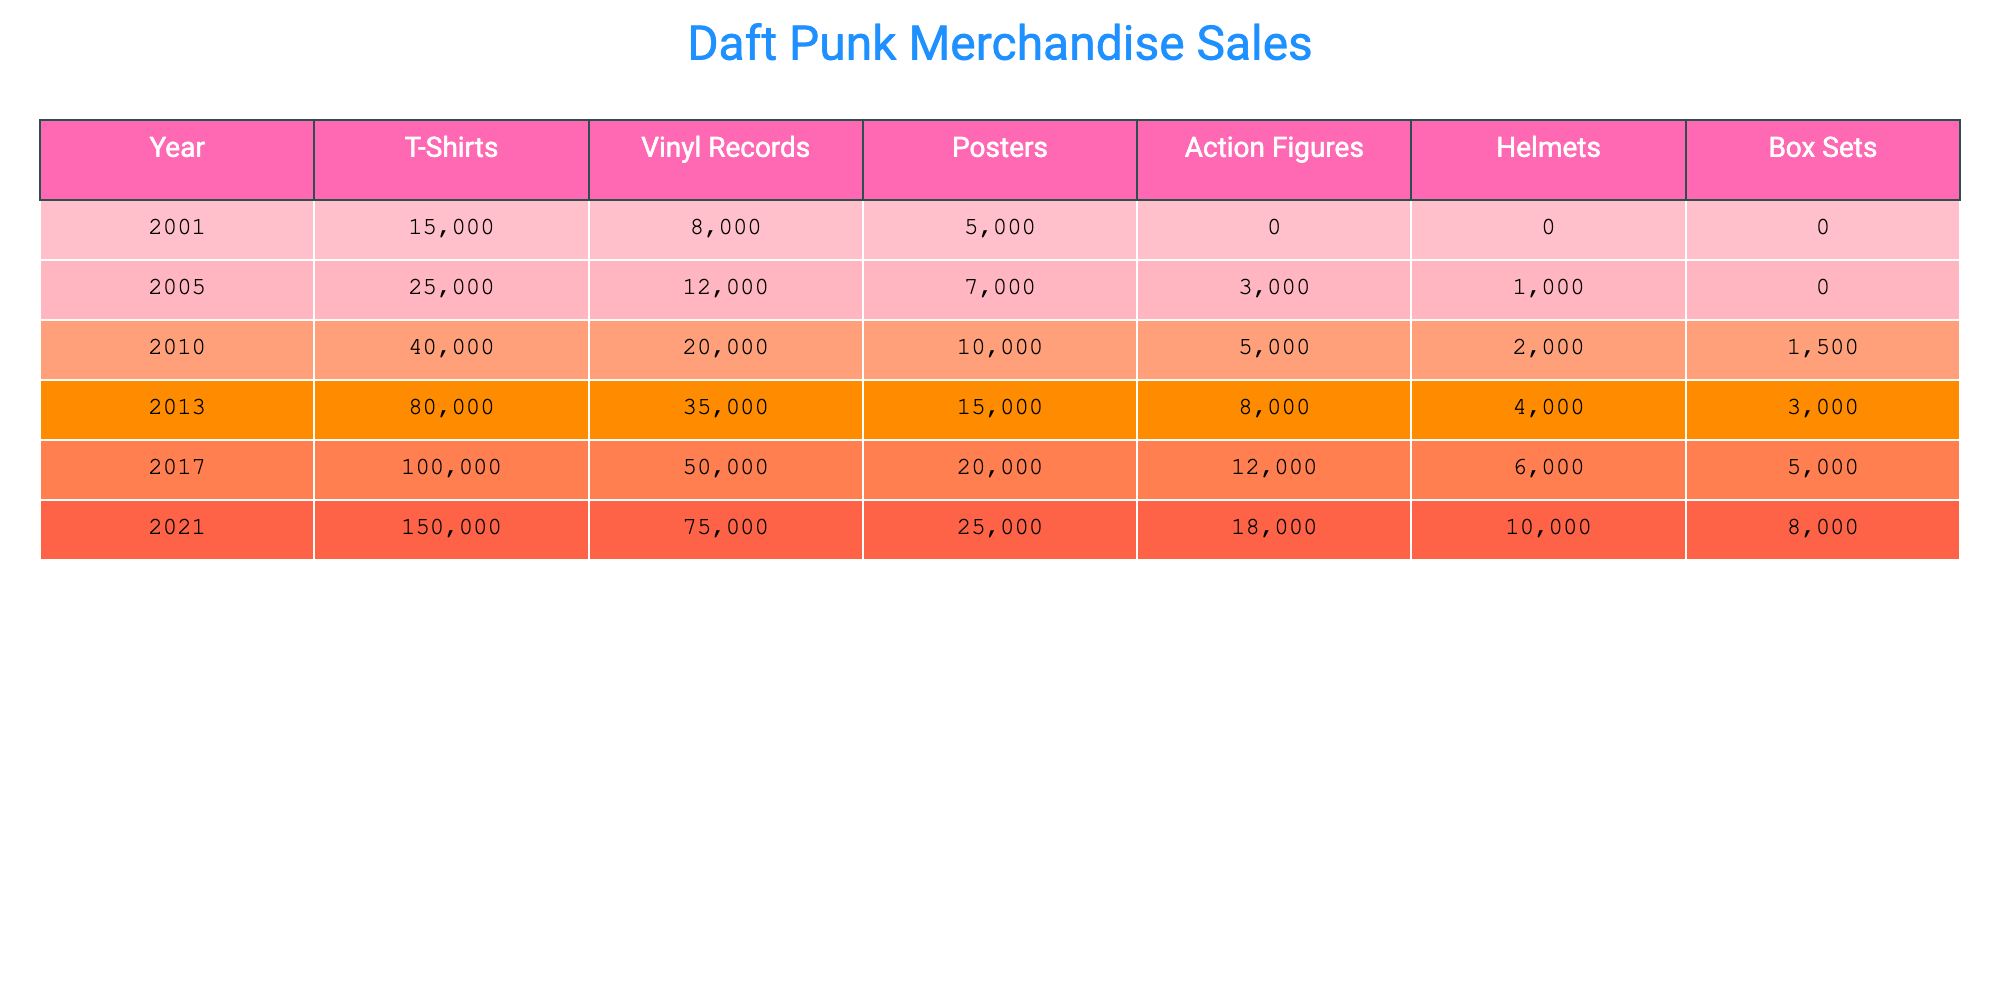What year had the highest merchandise sales for T-Shirts? The highest T-Shirt sales occurred in 2021, where 150,000 T-Shirts were sold, which is more than in any other year listed.
Answer: 2021 What was the total number of Action Figures sold from 2001 to 2021? The totals for Action Figures are: 0 (2001) + 3,000 (2005) + 5,000 (2010) + 8,000 (2013) + 12,000 (2017) + 18,000 (2021) = 46,000.
Answer: 46,000 Did the sales of Vinyl Records increase every year from 2001 to 2021? Yes, the sales of Vinyl Records consistently increased each year from 2001 to 2021, starting from 8,000 and ending with 75,000.
Answer: Yes Which product type experienced the most significant increase in sales from 2010 to 2013? To find the largest increase, we calculate the sales difference for each product type: T-Shirts: 80,000 - 40,000 = 40,000; Vinyl Records: 35,000 - 20,000 = 15,000; Posters: 15,000 - 10,000 = 5,000; Action Figures: 8,000 - 5,000 = 3,000; Helmets: 4,000 - 2,000 = 2,000; Box Sets: 3,000 - 1,500 = 1,500. The greatest increase was for T-Shirts with 40,000 more sold.
Answer: T-Shirts What is the average number of Posters sold from 2001 to 2021? To find the average, we sum the Posters sold over the years: 5,000 + 7,000 + 10,000 + 15,000 + 20,000 + 25,000 = 82,000. There are 6 years; 82,000 / 6 = approximately 13,667.
Answer: 13,667 Was the total number of Box Sets sold greater in 2021 than in 2017? Yes, in 2021, the sales were 8,000, while in 2017, they were 5,000, indicating that 2021 had greater sales for Box Sets.
Answer: Yes What was the overall merchandise sales trend from 2001 to 2021? The overall sales trend shows a significant increase from 2001 to 2021. Each product type, with the exception of Box Sets, showed growth, particularly notable are T-Shirts, which escalated dramatically.
Answer: Increasing trend 